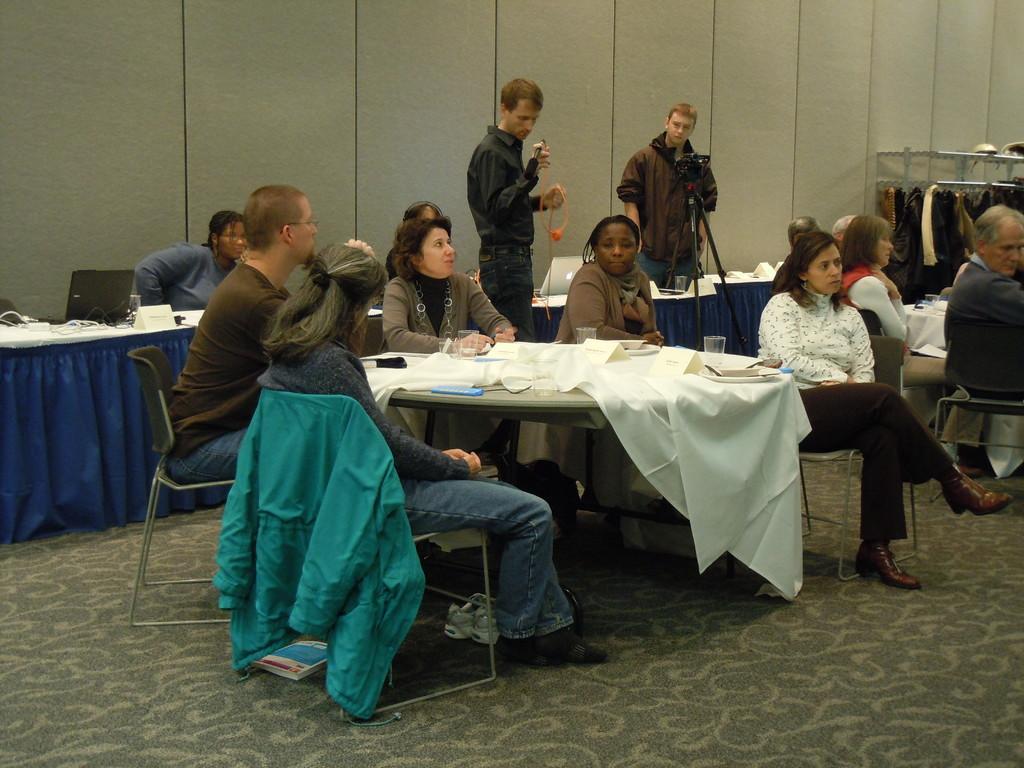Describe this image in one or two sentences. in this picture we can see two persons standing in front of a table. We can see all the persons sitting on chairs in front of a table and on the table we can see a white cloth, glasses, papers and mobile. This is a floor. Here we can see a book under the chair and a jacket in blue colour over a chair. This is a laptop on the table. On the background we can see clothes hanging over a stand. 